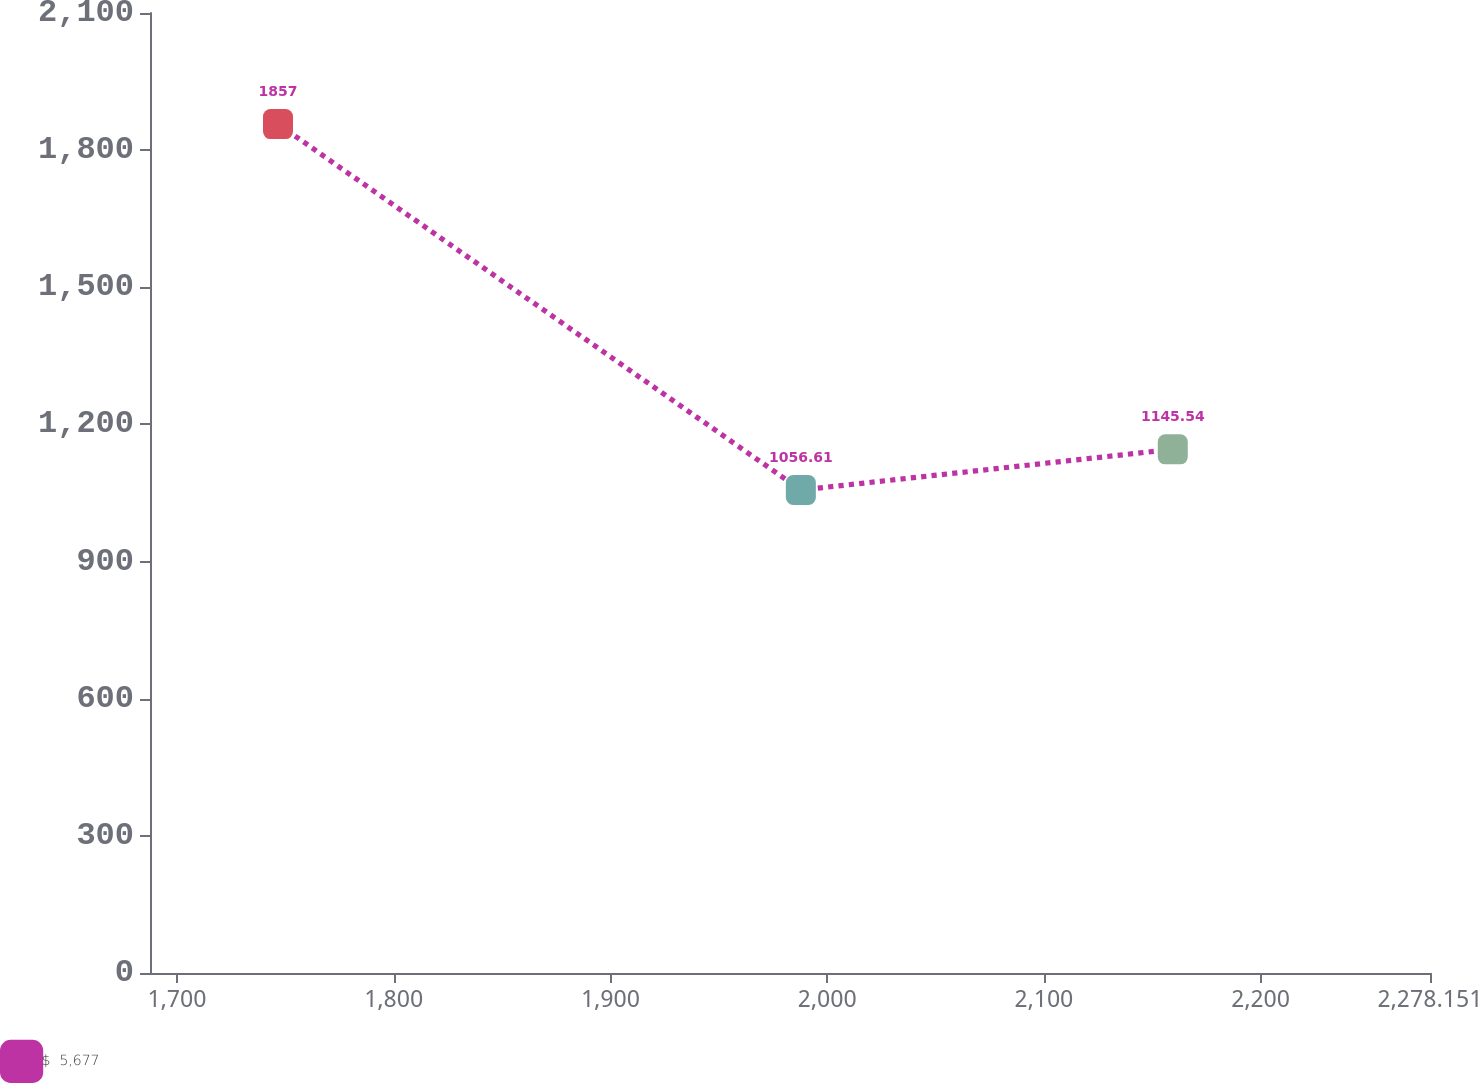Convert chart. <chart><loc_0><loc_0><loc_500><loc_500><line_chart><ecel><fcel>$  5,677<nl><fcel>1746.62<fcel>1857<nl><fcel>1987.86<fcel>1056.61<nl><fcel>2159.47<fcel>1145.54<nl><fcel>2337.21<fcel>967.68<nl></chart> 